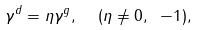<formula> <loc_0><loc_0><loc_500><loc_500>\gamma ^ { d } = \eta \gamma ^ { g } , \ \ ( \eta \neq 0 , \ - 1 ) ,</formula> 